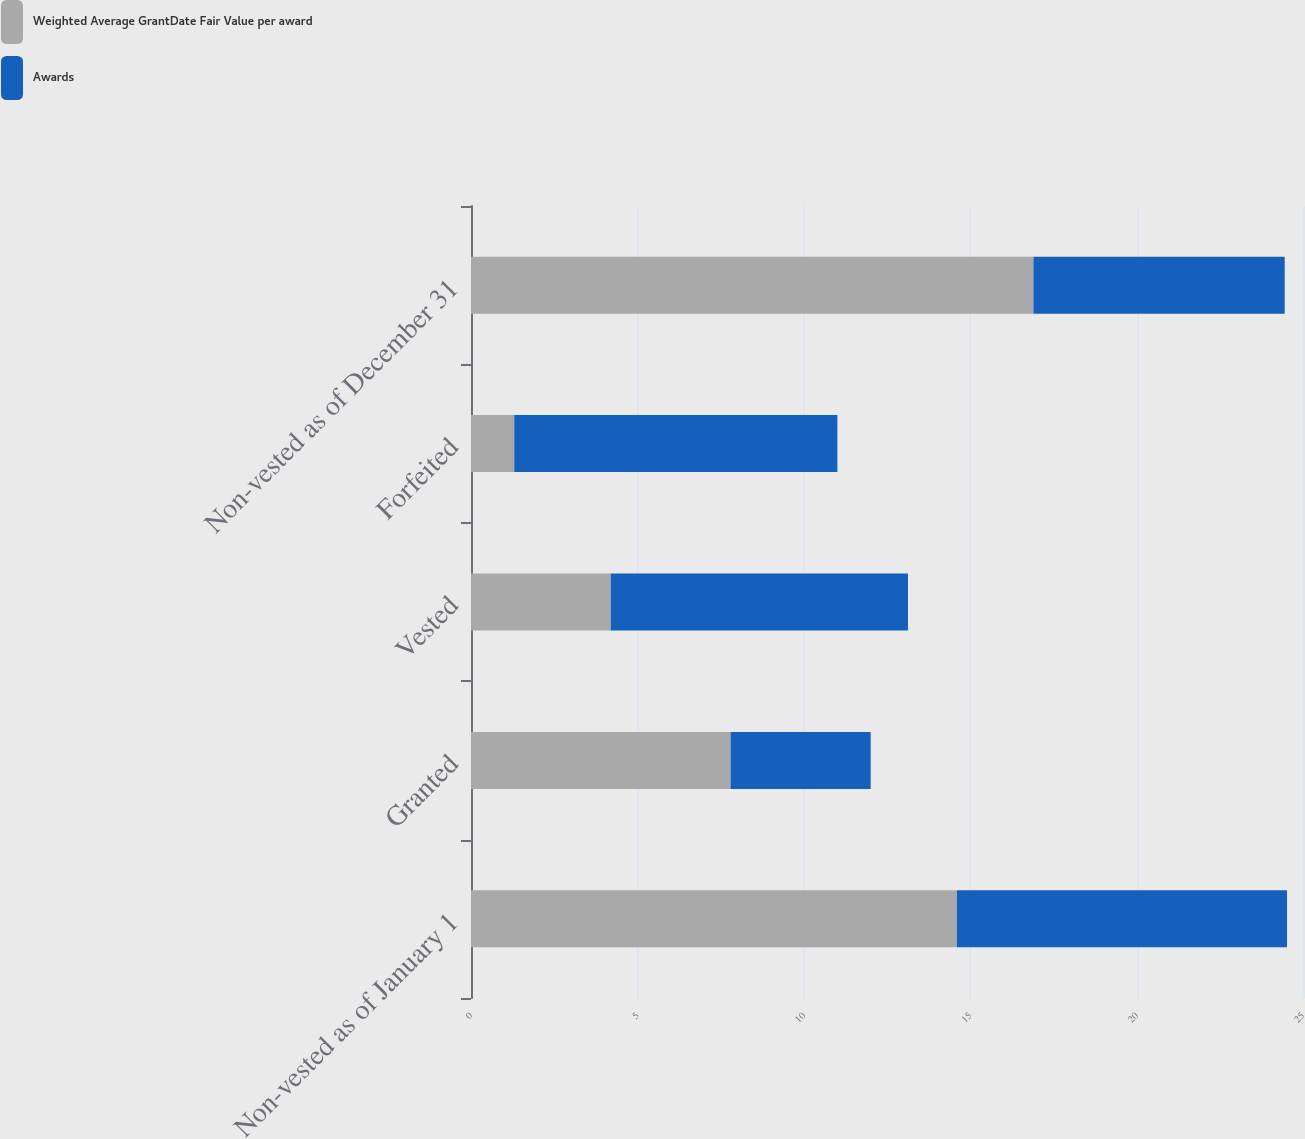Convert chart. <chart><loc_0><loc_0><loc_500><loc_500><stacked_bar_chart><ecel><fcel>Non-vested as of January 1<fcel>Granted<fcel>Vested<fcel>Forfeited<fcel>Non-vested as of December 31<nl><fcel>Weighted Average GrantDate Fair Value per award<fcel>14.6<fcel>7.8<fcel>4.2<fcel>1.3<fcel>16.9<nl><fcel>Awards<fcel>9.92<fcel>4.21<fcel>8.93<fcel>9.71<fcel>7.55<nl></chart> 